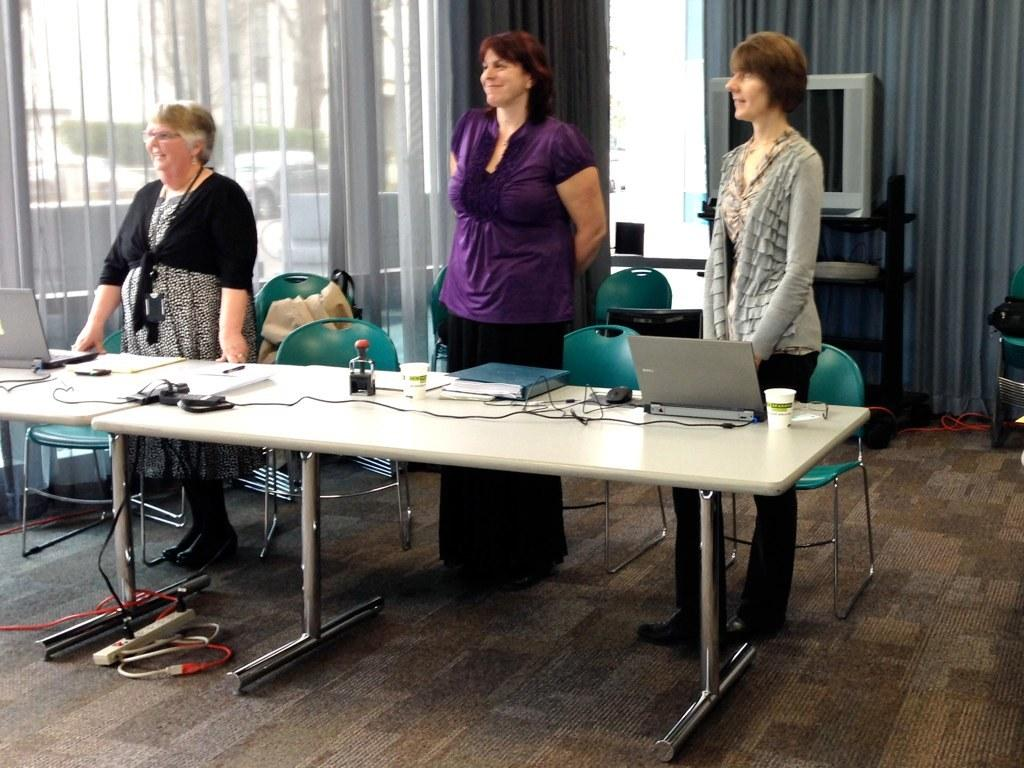How many women are in the image? There are three women in the image. What are the women doing in the image? The women are standing near tables. What items can be seen on the tables? There are laptops, books, mice, and wires on the table. What can be seen in the background of the image? There are chairs, curtains, and a television in the background. What type of existence do the boats have in the image? There are no boats present in the image. Is there a baseball game happening in the image? There is no indication of a baseball game in the image. 